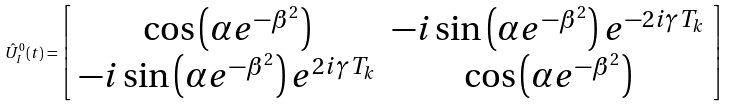<formula> <loc_0><loc_0><loc_500><loc_500>\hat { U } _ { I } ^ { 0 } ( t ) = \left [ \begin{array} { c c } \cos \left ( \alpha e ^ { - \beta ^ { 2 } } \right ) & - i \sin \left ( \alpha e ^ { - \beta ^ { 2 } } \right ) e ^ { - 2 i \gamma T _ { k } } \\ - i \sin \left ( \alpha e ^ { - \beta ^ { 2 } } \right ) e ^ { 2 i \gamma T _ { k } } & \cos \left ( \alpha e ^ { - \beta ^ { 2 } } \right ) \end{array} \right ]</formula> 